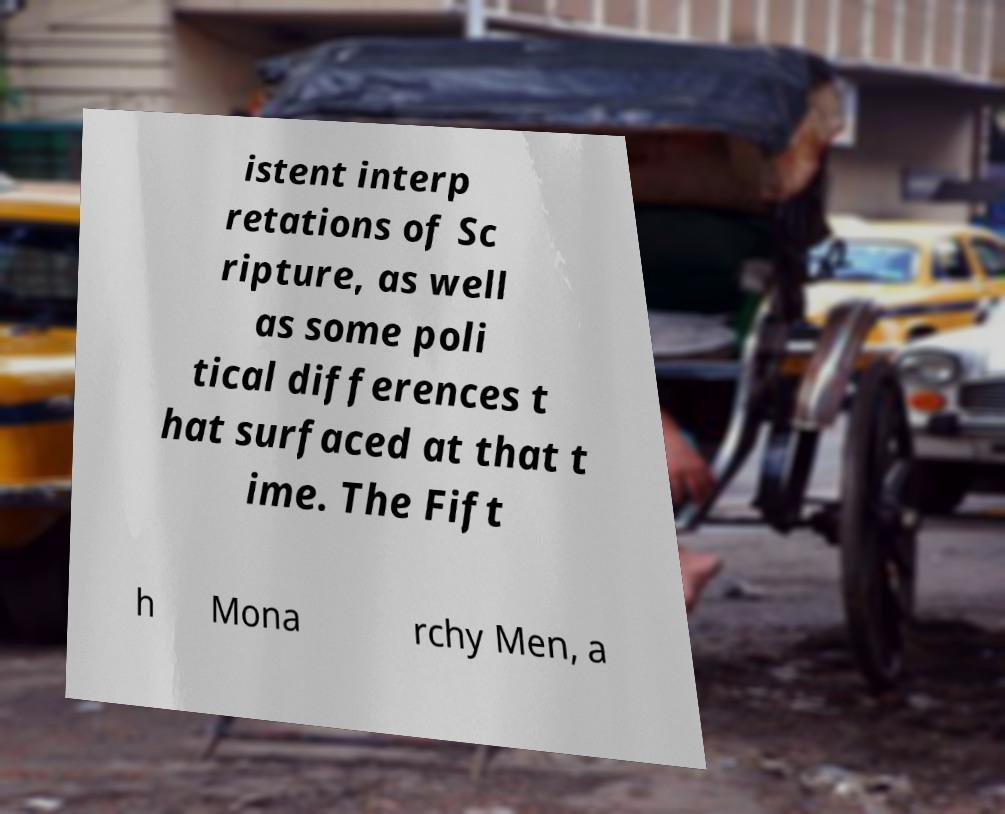Please read and relay the text visible in this image. What does it say? istent interp retations of Sc ripture, as well as some poli tical differences t hat surfaced at that t ime. The Fift h Mona rchy Men, a 